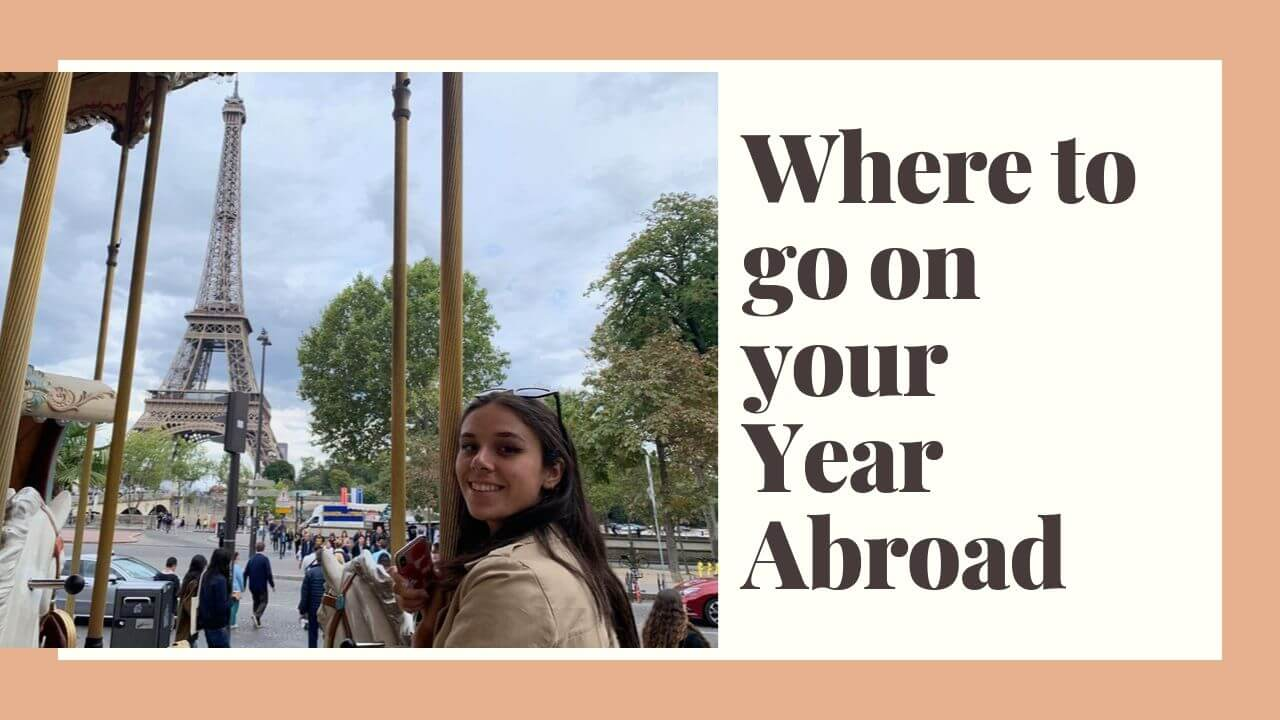Based on the depicted scene, what are some possible conversations happening between different groups of people around the carousel and Eiffel Tower? Near the carousel, a group of students might be excitedly discussing their next travel destinations and favorite experiences in Paris so far. Meanwhile, a young couple could be talking about how romantic the city feels and planning a dinner by the Seine River. A family nearby could be admiring the Eiffel Tower and sharing historical facts, while their children eagerly plan which rides to go on next. Everyone seems to be enjoying the vibrant atmosphere, their conversations filled with laughter, curiosity, and awe. 